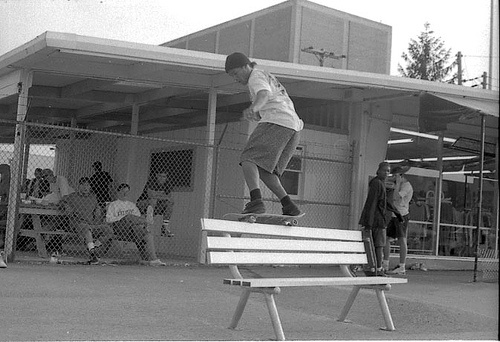Describe the objects in this image and their specific colors. I can see bench in lightgray, gray, darkgray, and black tones, people in lightgray, gray, darkgray, and black tones, people in gray, black, and lightgray tones, people in black, gray, and lightgray tones, and people in lightgray, gray, black, and silver tones in this image. 